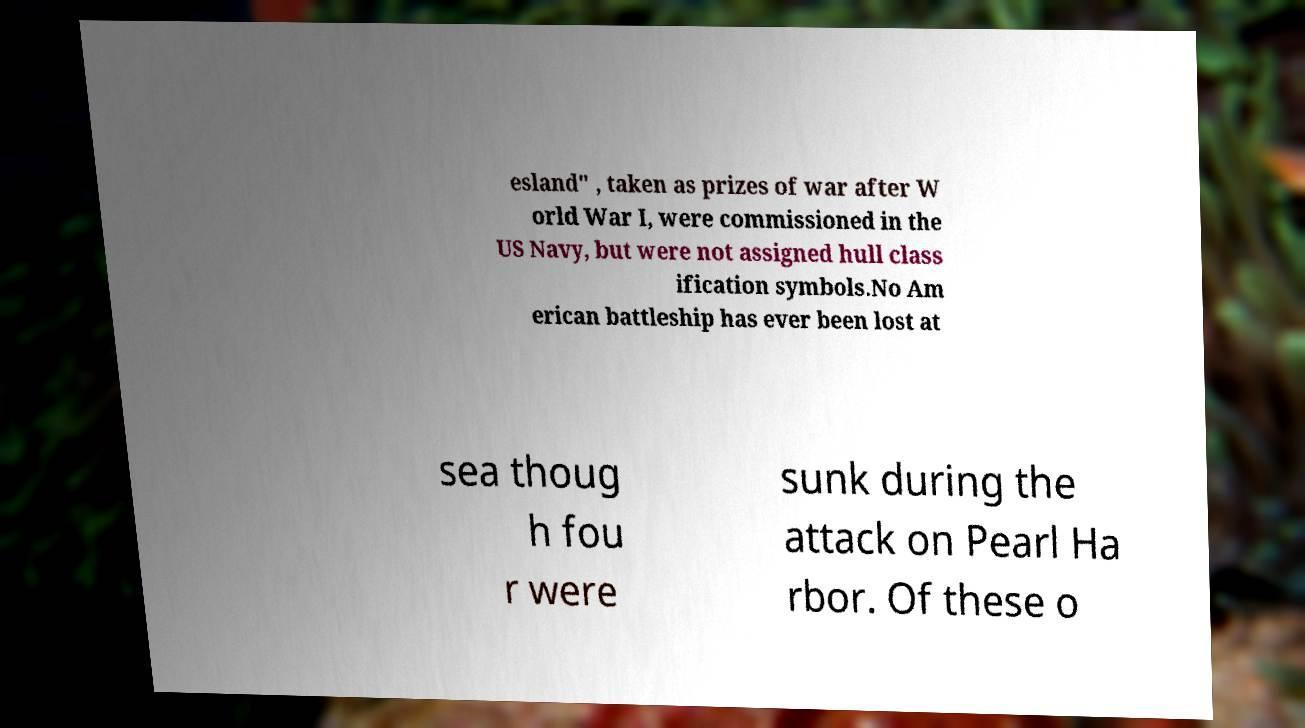What messages or text are displayed in this image? I need them in a readable, typed format. esland" , taken as prizes of war after W orld War I, were commissioned in the US Navy, but were not assigned hull class ification symbols.No Am erican battleship has ever been lost at sea thoug h fou r were sunk during the attack on Pearl Ha rbor. Of these o 